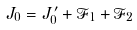<formula> <loc_0><loc_0><loc_500><loc_500>& J _ { 0 } = J ^ { \prime } _ { 0 } + \mathcal { F } _ { 1 } + \mathcal { F } _ { 2 } &</formula> 